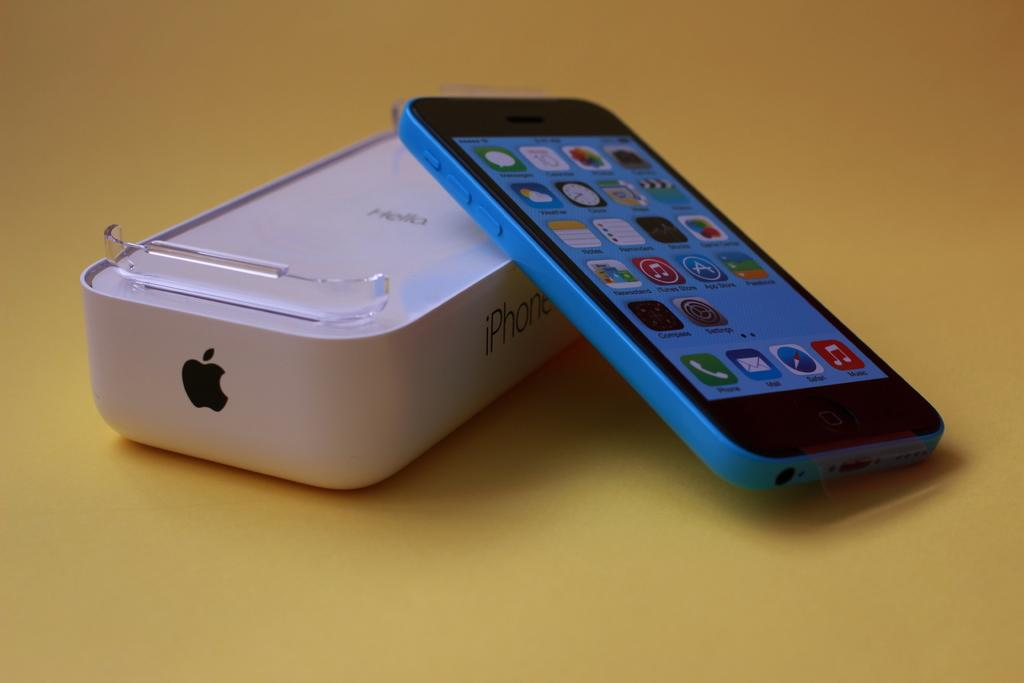<image>
Create a compact narrative representing the image presented. an iPhone case that has the word hello on it 